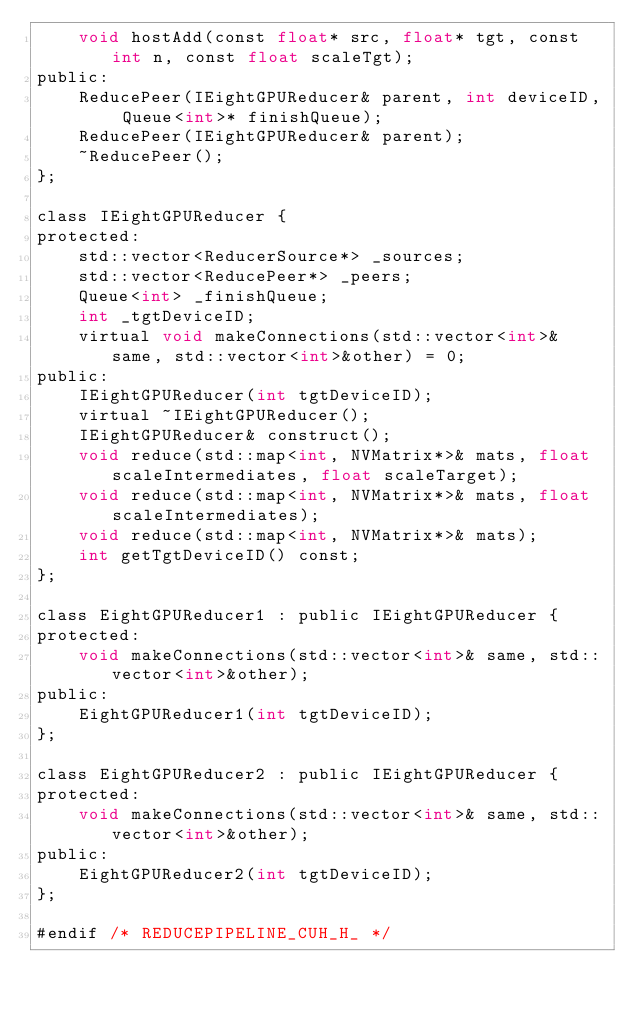<code> <loc_0><loc_0><loc_500><loc_500><_Cuda_>    void hostAdd(const float* src, float* tgt, const int n, const float scaleTgt);
public:
    ReducePeer(IEightGPUReducer& parent, int deviceID, Queue<int>* finishQueue);
    ReducePeer(IEightGPUReducer& parent);
    ~ReducePeer();
};

class IEightGPUReducer {
protected:
    std::vector<ReducerSource*> _sources;
    std::vector<ReducePeer*> _peers;
    Queue<int> _finishQueue;
    int _tgtDeviceID;
    virtual void makeConnections(std::vector<int>& same, std::vector<int>&other) = 0;
public:
    IEightGPUReducer(int tgtDeviceID);
    virtual ~IEightGPUReducer();
    IEightGPUReducer& construct();
    void reduce(std::map<int, NVMatrix*>& mats, float scaleIntermediates, float scaleTarget);
    void reduce(std::map<int, NVMatrix*>& mats, float scaleIntermediates);
    void reduce(std::map<int, NVMatrix*>& mats);
    int getTgtDeviceID() const;
};

class EightGPUReducer1 : public IEightGPUReducer {
protected:
    void makeConnections(std::vector<int>& same, std::vector<int>&other);
public:
    EightGPUReducer1(int tgtDeviceID);
};

class EightGPUReducer2 : public IEightGPUReducer {
protected:
    void makeConnections(std::vector<int>& same, std::vector<int>&other);
public:
    EightGPUReducer2(int tgtDeviceID);
};

#endif /* REDUCEPIPELINE_CUH_H_ */
</code> 